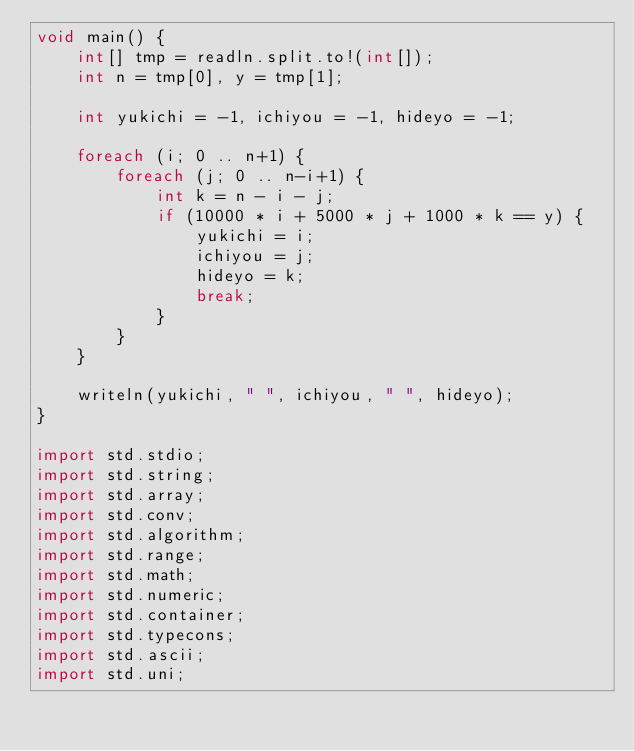Convert code to text. <code><loc_0><loc_0><loc_500><loc_500><_D_>void main() {
    int[] tmp = readln.split.to!(int[]);
    int n = tmp[0], y = tmp[1];

    int yukichi = -1, ichiyou = -1, hideyo = -1;

    foreach (i; 0 .. n+1) {
        foreach (j; 0 .. n-i+1) {
            int k = n - i - j;
            if (10000 * i + 5000 * j + 1000 * k == y) {
                yukichi = i;
                ichiyou = j;
                hideyo = k;
                break;
            }
        }
    }

    writeln(yukichi, " ", ichiyou, " ", hideyo);
}

import std.stdio;
import std.string;
import std.array;
import std.conv;
import std.algorithm;
import std.range;
import std.math;
import std.numeric;
import std.container;
import std.typecons;
import std.ascii;
import std.uni;</code> 